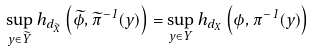<formula> <loc_0><loc_0><loc_500><loc_500>\sup _ { y \in \widetilde { Y } } h _ { d _ { \widetilde { X } } } \left ( \widetilde { \phi } , \widetilde { \pi } ^ { - 1 } ( y ) \right ) = \sup _ { y \in Y } h _ { d _ { X } } \left ( \phi , \pi ^ { - 1 } ( y ) \right )</formula> 